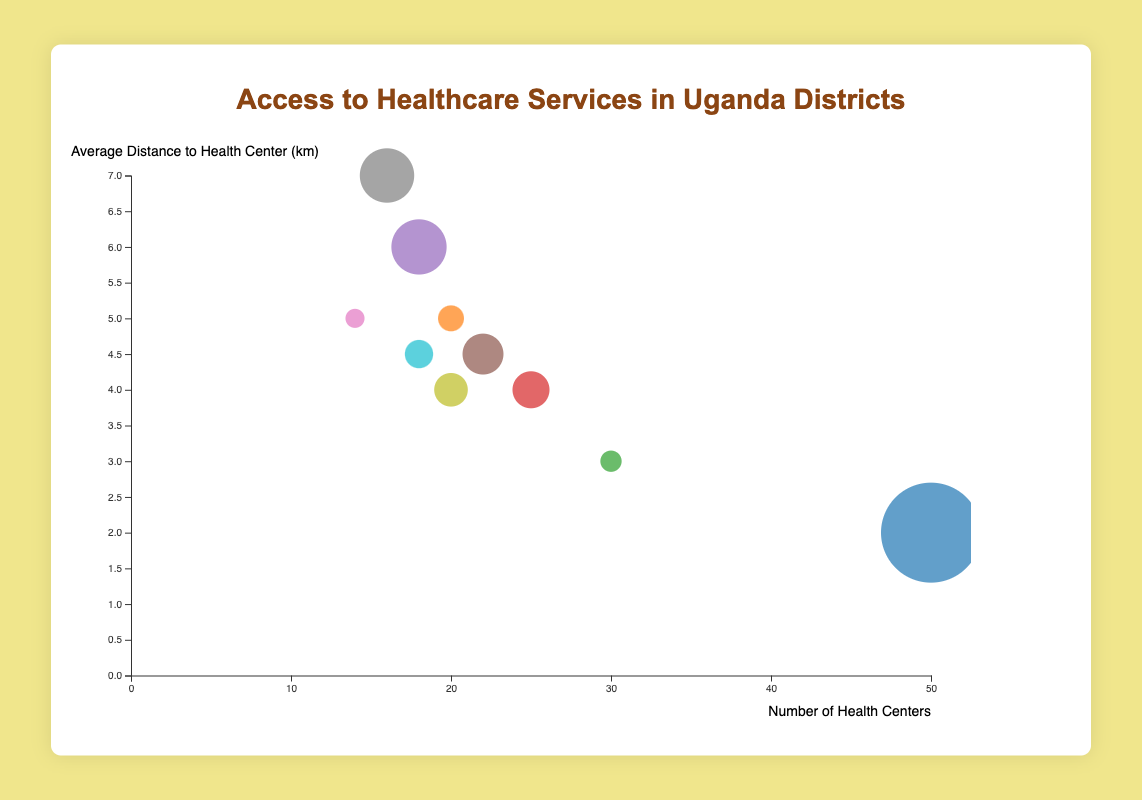How many districts are displayed in the bubble chart? Count the total number of bubble data points on the chart, each representing a district.
Answer: 10 Which district has the largest bubble in the chart, and what does it represent? The largest bubble represents the district with the highest population. In the chart, the size of the bubble indicates population. Visually locate the largest bubble.
Answer: Kampala What are the axis titles for the x-axis and y-axis on the chart? Identify the titles located near the end of the x-axis and the start of the y-axis to find the labeling of the axes.
Answer: Number of Health Centers (x-axis) and Average Distance to Health Center (km) (y-axis) Which district has the highest number of health centers, and how many are there? Look for the bubble farthest to the right on the x-axis because the x-axis represents the number of health centers.
Answer: Kampala, 50 Which district has the smallest average distance to a health center? Identify the bubble located lowest on the y-axis since the y-axis represents the average distance to a health center (km).
Answer: Kampala What is the average number of health centers across all districts? Calculate the sum of health centers for all districts and divide by the total number of districts: (50 + 20 + 30 + 25 + 18 + 22 + 14 + 16 + 20 + 18) / 10.
Answer: 23.3 Compare the average distance to a health center in Kampala and Kasese. Which district has better access? Visually compare the y-axis positions of the bubbles for Kampala and Kasese; the lower the bubble, the smaller the distance.
Answer: Kampala has better access, 2 km compared to Kasese's 7 km What is the total population of Gulu, Mbarara, and Jinja combined? Sum the populations of the three districts: 275,000 (Gulu) + 195,013 (Mbarara) + 467,100 (Jinja).
Answer: 937,113 Which district appears to have the best overall access to healthcare services combining both number of health centers and distance? Identify the district with high x-axis value (more health centers) and low y-axis value (less distance). Visually confirm which bubble is farthest right and lowest.
Answer: Kampala 